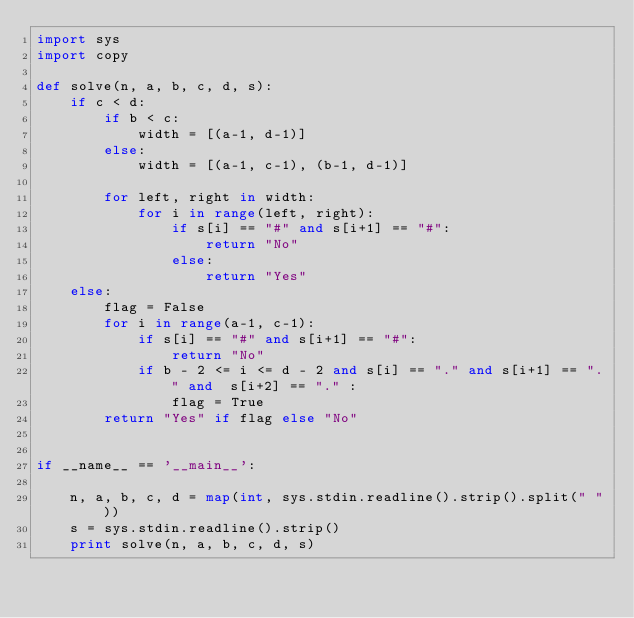<code> <loc_0><loc_0><loc_500><loc_500><_Python_>import sys
import copy

def solve(n, a, b, c, d, s):
    if c < d:
        if b < c:
            width = [(a-1, d-1)]
        else:
            width = [(a-1, c-1), (b-1, d-1)]

        for left, right in width:
            for i in range(left, right):
                if s[i] == "#" and s[i+1] == "#":
                    return "No"
                else:
                    return "Yes"
    else:
        flag = False
        for i in range(a-1, c-1):
            if s[i] == "#" and s[i+1] == "#":
                return "No"
            if b - 2 <= i <= d - 2 and s[i] == "." and s[i+1] == "." and  s[i+2] == "." :
                flag = True
        return "Yes" if flag else "No"


if __name__ == '__main__':

    n, a, b, c, d = map(int, sys.stdin.readline().strip().split(" "))
    s = sys.stdin.readline().strip()
    print solve(n, a, b, c, d, s)</code> 